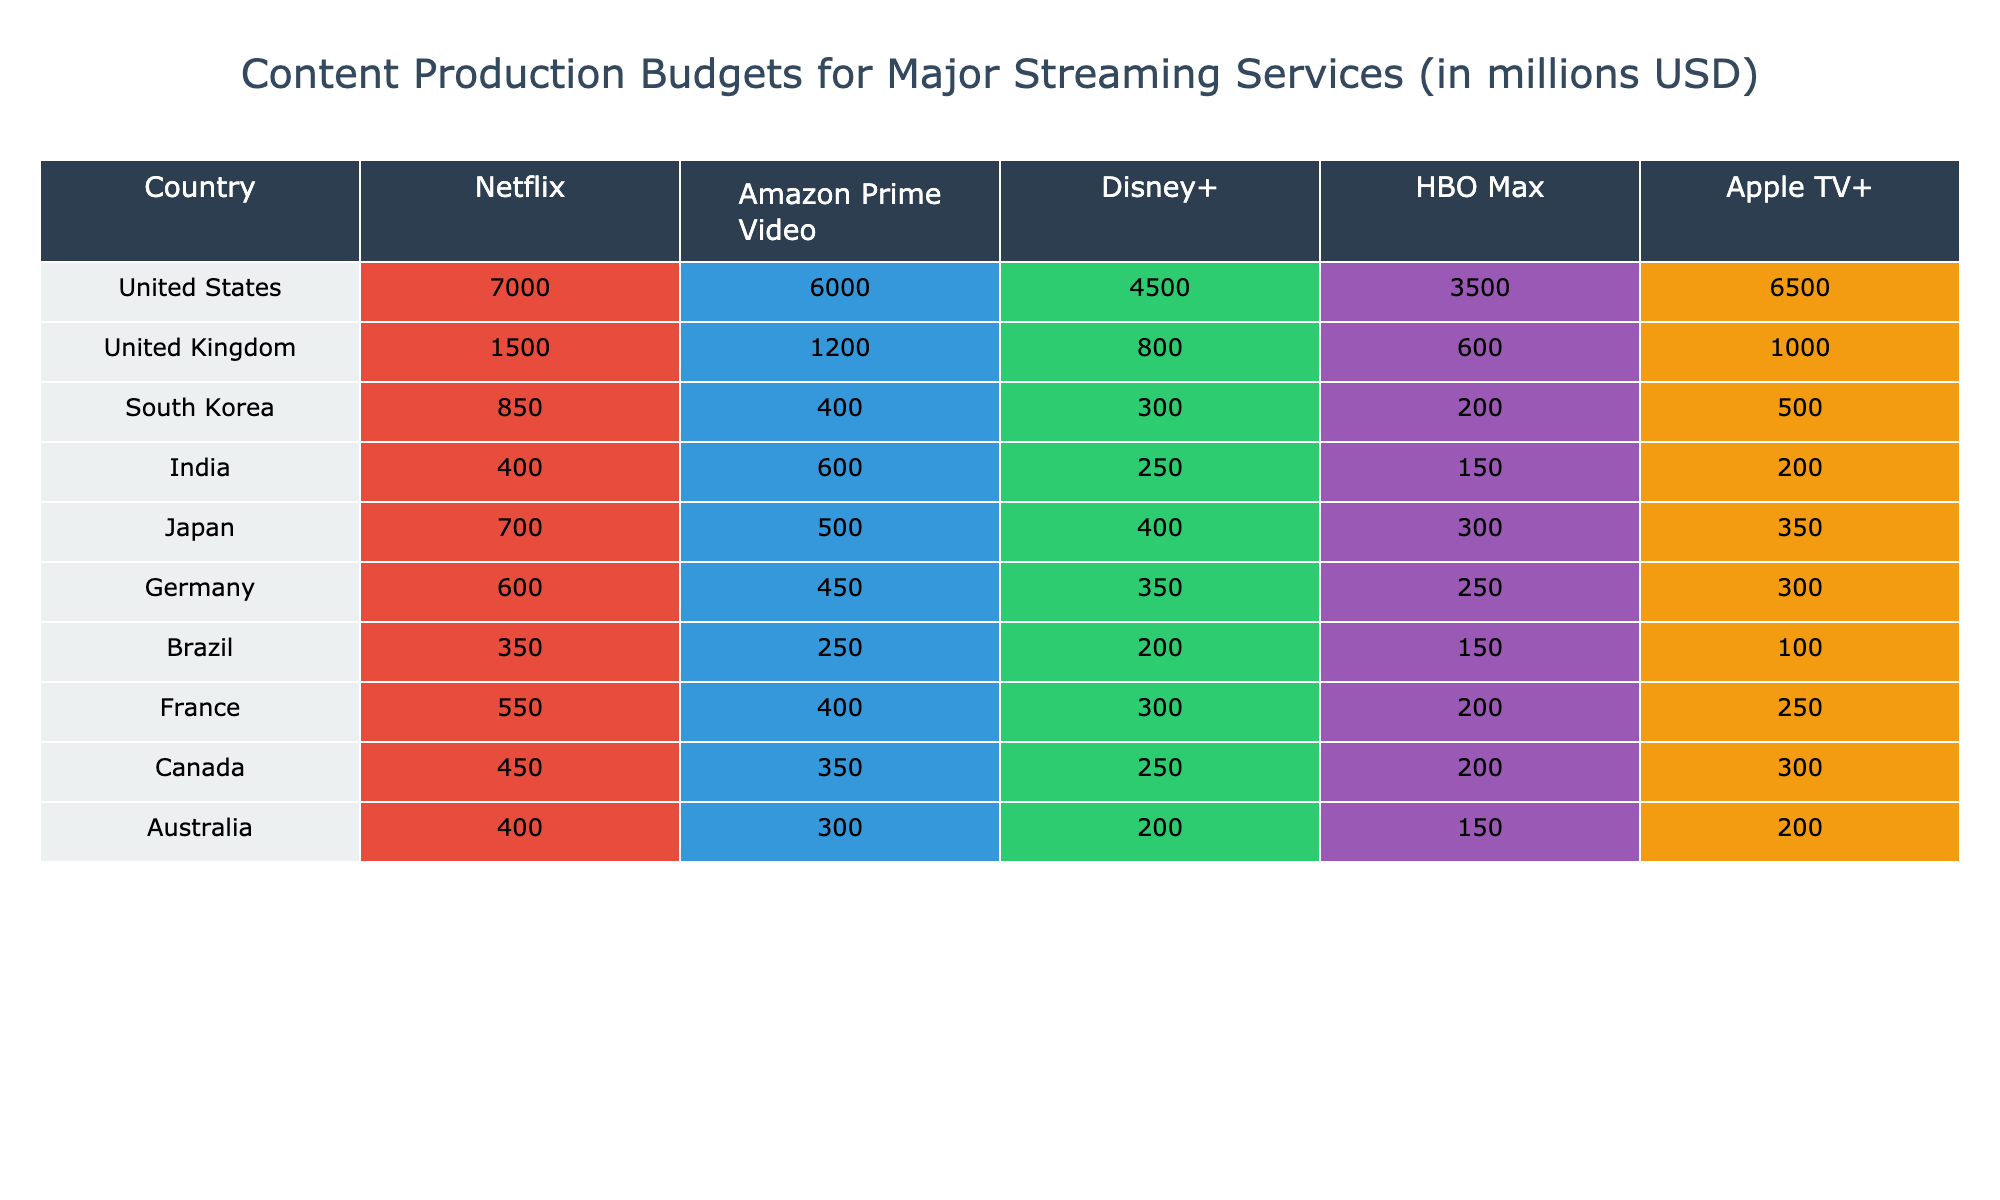What is the highest content production budget for Netflix? The table shows that the United States has the highest budget for Netflix at 7000 million USD.
Answer: 7000 million USD Which country has the lowest production budget for Disney+? The table indicates that Brazil has the lowest budget for Disney+ at 200 million USD.
Answer: 200 million USD What is the total production budget for Amazon Prime Video in the United States and Canada combined? The budgets for Amazon Prime Video in the United States (6000 million USD) and Canada (350 million USD) sum up to 6000 + 350 = 6350 million USD.
Answer: 6350 million USD Does South Korea have a larger budget for HBO Max compared to India? South Korea has a budget of 200 million USD for HBO Max, while India has a budget of 150 million USD. Since 200 is greater than 150, the answer is yes.
Answer: Yes What is the average budget for Apple TV+ across all countries listed? The budgets for Apple TV+ are: 6500 (USA), 1000 (UK), 500 (South Korea), 200 (India), 350 (Japan), 300 (Germany), 100 (Brazil), 250 (France), 300 (Canada), and 200 (Australia). Summing these gives 6500 + 1000 + 500 + 200 + 350 + 300 + 100 + 250 + 300 + 200 = 8100 million USD. There are 10 countries, so the average is 8100 / 10 = 810 million USD.
Answer: 810 million USD Which streaming service has the highest total budget across all countries? By summing the budgets for each streaming service across all countries, we find: Netflix = 7000 + 1500 + 850 + 400 + 700 + 600 + 350 + 550 + 450 + 400 = 9995 million USD. Amazon Prime Video = 6000 + 1200 + 400 + 600 + 500 + 450 + 250 + 400 + 350 + 300 =  9430 million USD. Disney+ = 4500 + 800 + 300 + 250 + 400 + 350 + 200 + 300 + 250 + 200 =  6830 million USD. HBO Max = 3500 + 600 + 200 + 150 + 300 + 250 + 150 + 200 + 200 + 150 =  3450 million USD. Apple TV+ = 6500 + 1000 + 500 + 200 + 350 + 300 + 100 + 250 + 300 + 200 =  8100 million USD. Thus, Netflix has the highest total budget.
Answer: Netflix How much more does the United States spend on Netflix compared to Brazil? The budget for Netflix in the United States is 7000 million USD, while in Brazil it is 350 million USD. The difference between them is 7000 - 350 = 6650 million USD.
Answer: 6650 million USD Is the total budget for HBO Max in the United Kingdom greater than the total budget for Disney+ in India? The budget for HBO Max in the UK is 600 million USD and for Disney+ in India is 250 million USD. Since 600 is greater than 250, the answer is yes.
Answer: Yes Which country has the closest production budgets for Netflix and Amazon Prime Video? By comparing the budgets in each country: United States (7000 vs. 6000), United Kingdom (1500 vs. 1200), South Korea (850 vs. 400), India (400 vs. 600), Japan (700 vs. 500), Germany (600 vs. 450), Brazil (350 vs. 250), France (550 vs. 400), Canada (450 vs. 350), and Australia (400 vs. 300), the country with the closest budgets is Japan with 700 for Netflix and 500 for Amazon Prime Video, a difference of 200 million USD.
Answer: Japan What is the difference in the production budget for Amazon Prime Video between the United States and Canada? The budget for Amazon Prime Video in the United States is 6000 million USD, while in Canada it is 350 million USD. The difference is 6000 - 350 = 5650 million USD.
Answer: 5650 million USD 